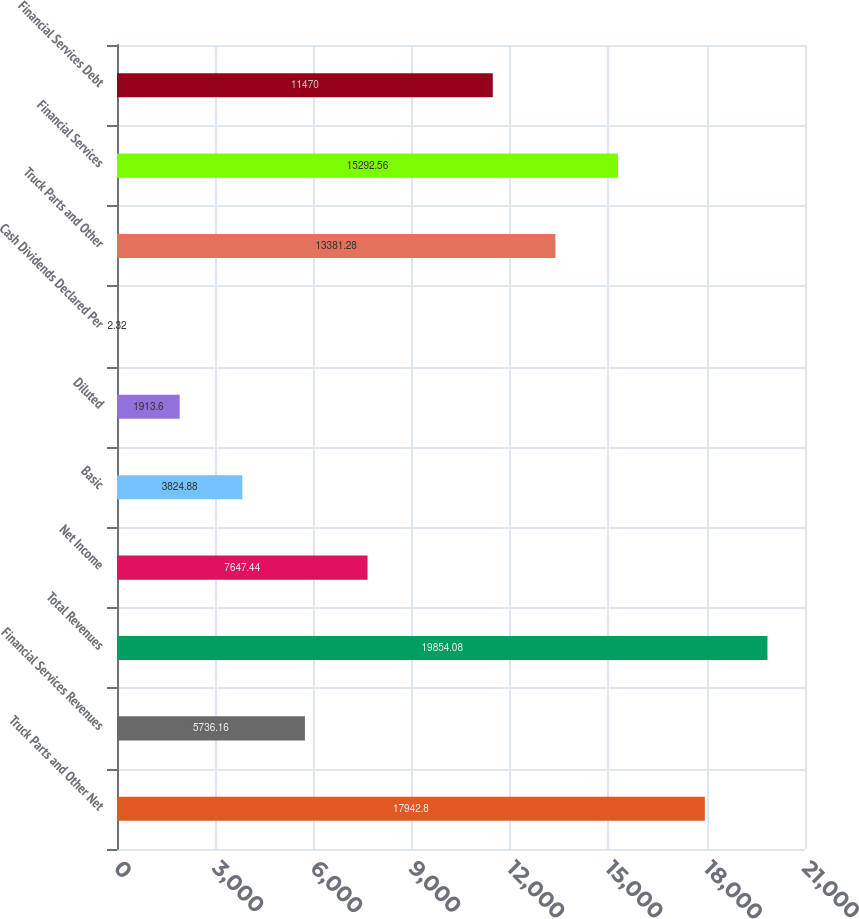<chart> <loc_0><loc_0><loc_500><loc_500><bar_chart><fcel>Truck Parts and Other Net<fcel>Financial Services Revenues<fcel>Total Revenues<fcel>Net Income<fcel>Basic<fcel>Diluted<fcel>Cash Dividends Declared Per<fcel>Truck Parts and Other<fcel>Financial Services<fcel>Financial Services Debt<nl><fcel>17942.8<fcel>5736.16<fcel>19854.1<fcel>7647.44<fcel>3824.88<fcel>1913.6<fcel>2.32<fcel>13381.3<fcel>15292.6<fcel>11470<nl></chart> 